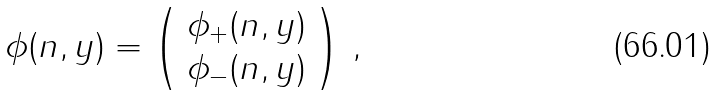Convert formula to latex. <formula><loc_0><loc_0><loc_500><loc_500>\phi ( n , y ) = \left ( \begin{array} { c } \phi _ { + } ( n , y ) \\ \phi _ { - } ( n , y ) \end{array} \right ) \, ,</formula> 